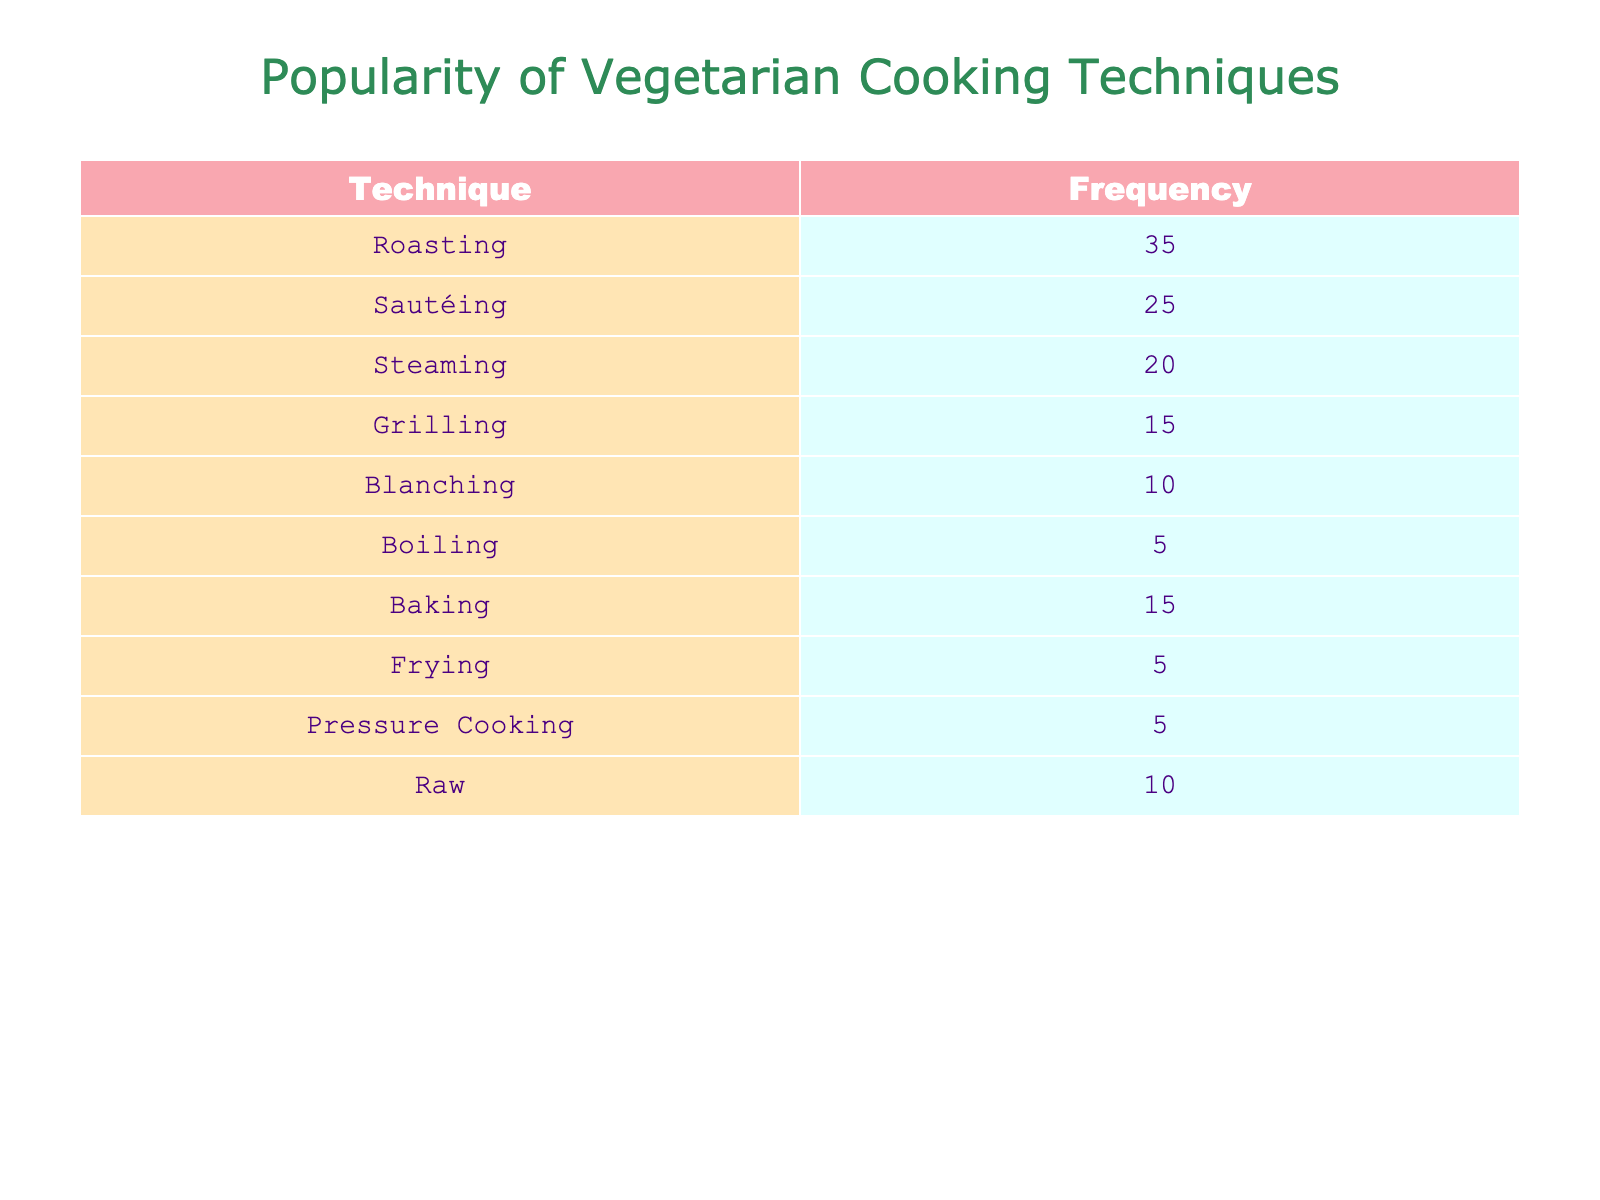What is the most popular cooking technique in vegetarian recipes? The table shows the frequencies of various cooking techniques. The technique with the highest frequency is Roasting, which has a frequency of 35.
Answer: Roasting How many cooking techniques are listed in the table? The table includes the following techniques: Roasting, Sautéing, Steaming, Grilling, Blanching, Boiling, Baking, Frying, Pressure Cooking, and Raw. Counting these, there are 10 techniques in total.
Answer: 10 What is the total frequency of the boiling and frying techniques? The frequency for Boiling is 5 and for Frying is also 5. Adding these together gives 5 + 5 = 10, which is the total frequency for these two techniques.
Answer: 10 Is sautéing more popular than grilling? The table indicates that Sautéing has a frequency of 25, while Grilling has a frequency of 15. Since 25 is greater than 15, Sautéing is indeed more popular than Grilling.
Answer: Yes What is the median frequency of all cooking techniques? First, list the frequencies in ascending order: [5, 5, 5, 10, 15, 15, 20, 25, 35]. There are 10 values, so the median is the average of the 5th and 6th values: (15 + 15) / 2 = 15.
Answer: 15 How many techniques have a frequency of 15 or more? The techniques with 15 or more frequencies are Roasting (35), Sautéing (25), Steaming (20), and Baking (15). Counting these gives a total of 4 techniques.
Answer: 4 What is the difference between the frequency of roasting and the frequency of boiling? From the table, the frequency of Roasting is 35 and for Boiling, it is 5. The difference is calculated as 35 - 5 = 30.
Answer: 30 Which cooking technique has the lowest frequency, and what is that frequency? By examining the table, we can see that Boiling, Frying, and Pressure Cooking all have the lowest frequency, which is 5.
Answer: Frying, 5 